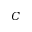Convert formula to latex. <formula><loc_0><loc_0><loc_500><loc_500>C</formula> 